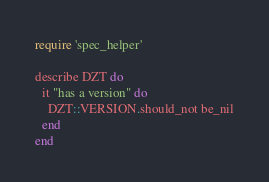<code> <loc_0><loc_0><loc_500><loc_500><_Ruby_>require 'spec_helper'

describe DZT do
  it "has a version" do
    DZT::VERSION.should_not be_nil
  end
end
</code> 